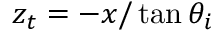<formula> <loc_0><loc_0><loc_500><loc_500>z _ { t } = - x / \tan \theta _ { i }</formula> 